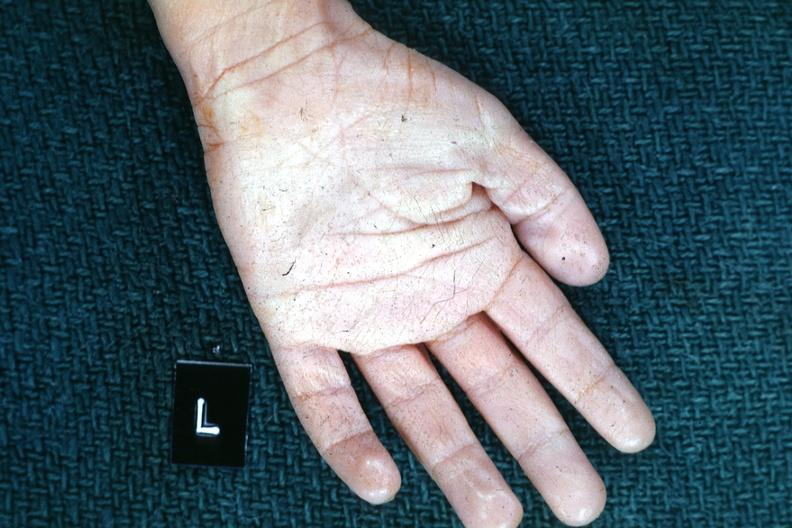does this image show left hand?
Answer the question using a single word or phrase. Yes 